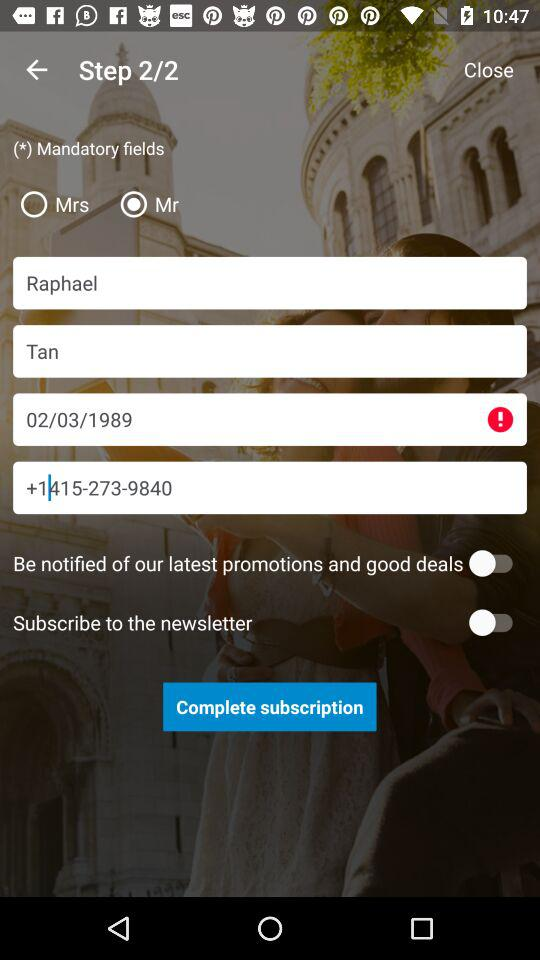What is the date of birth? The date of birth is February 3, 1989. 